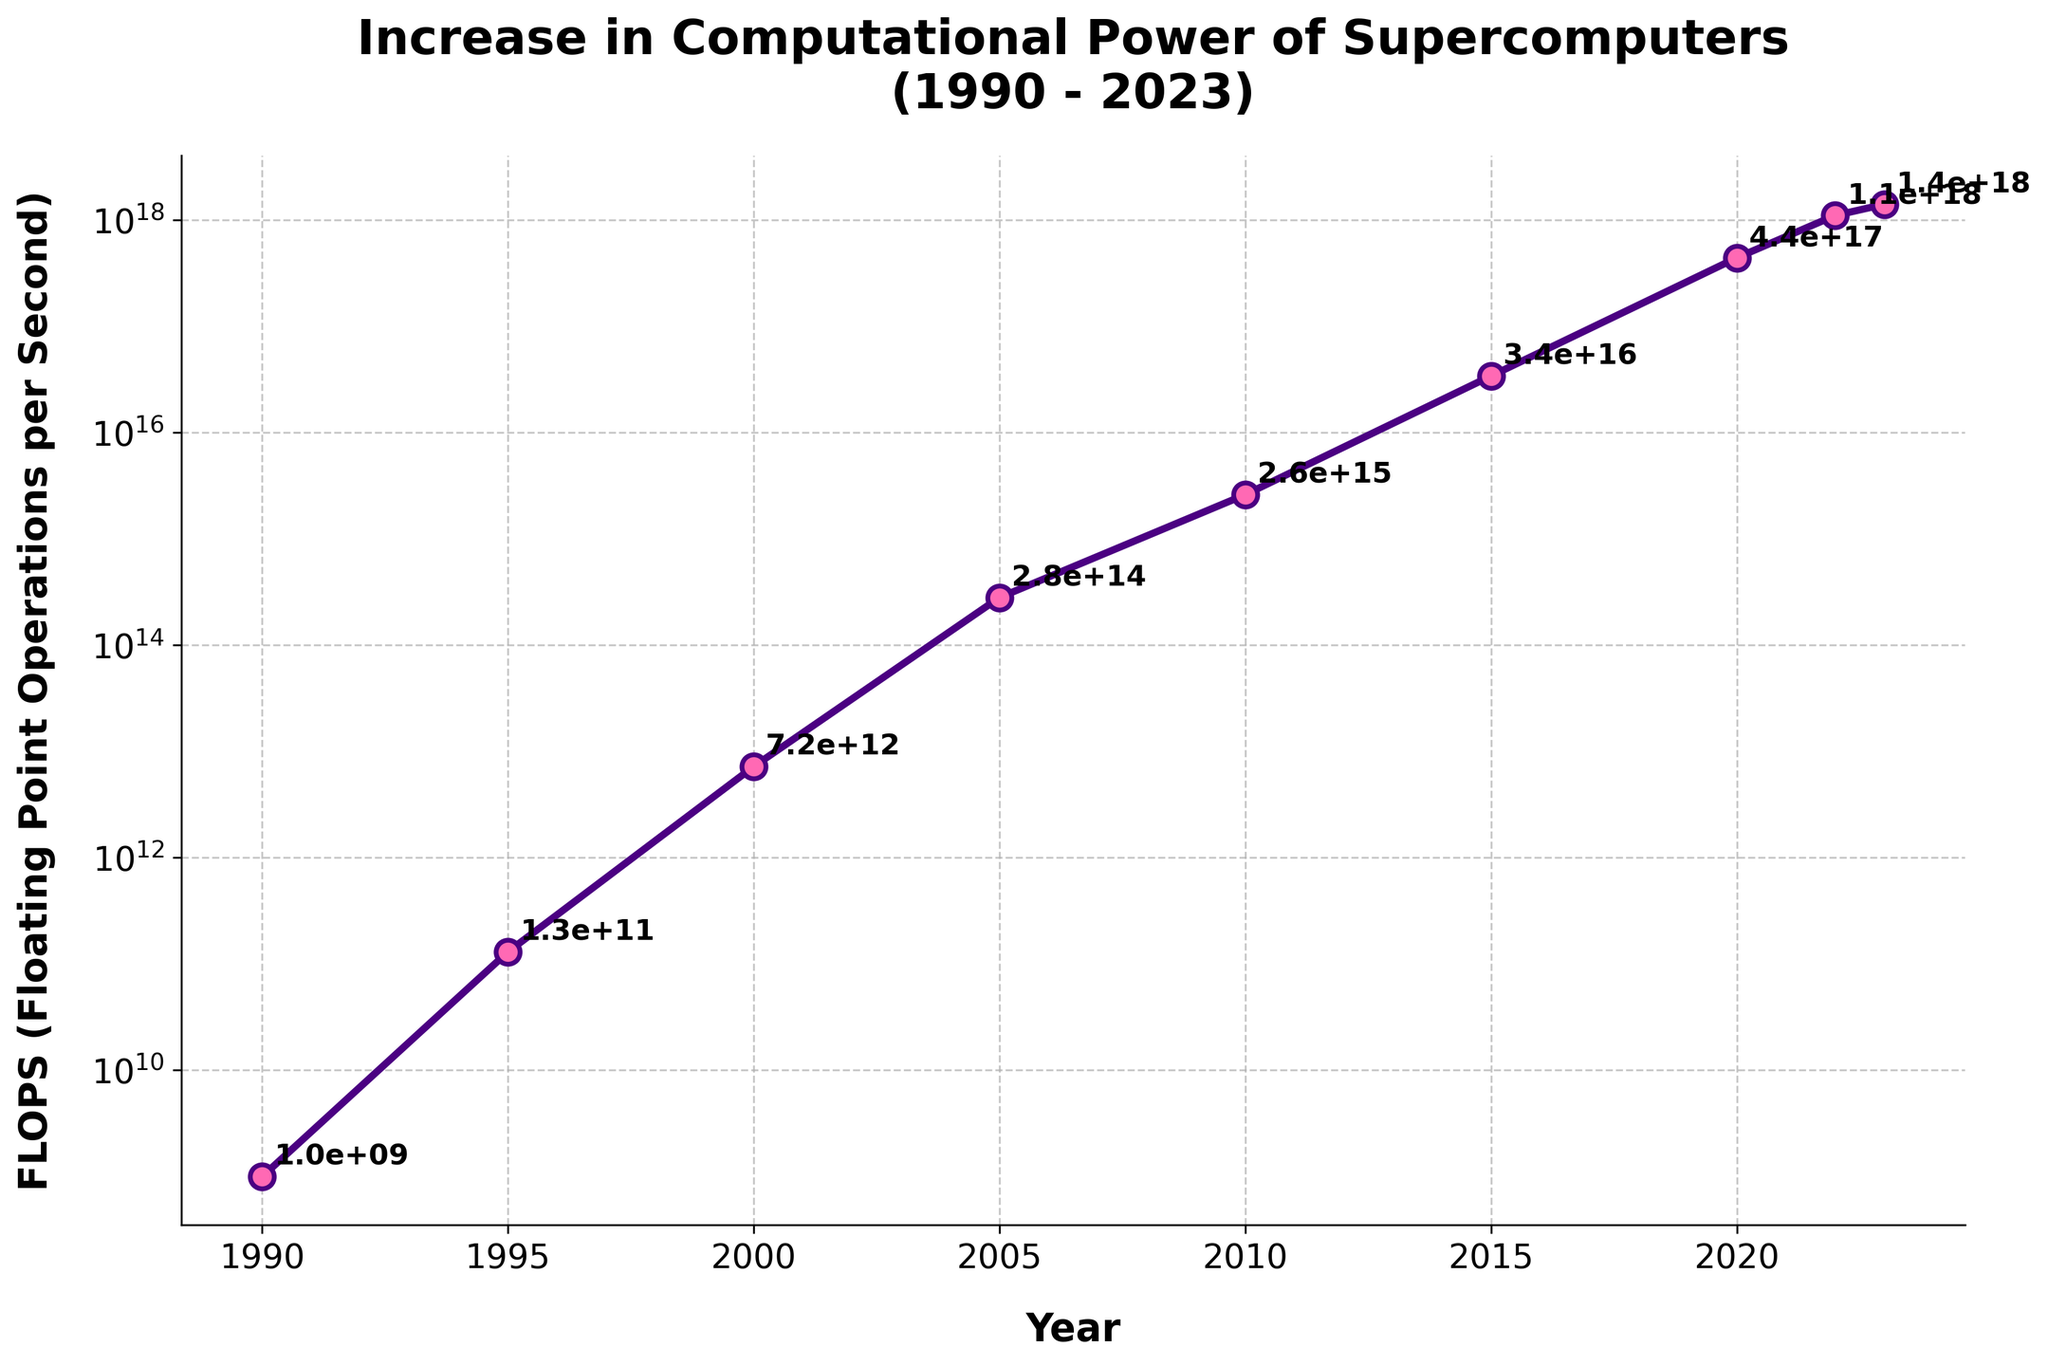What is the overall trend in computational power (FLOPS) from 1990 to 2023? The trend can be observed by simply looking at the line connecting the data points on the plot, which shows a general upward trajectory. This indicates that the computational power (FLOPS) of supercomputers has increased significantly from 1990 to 2023.
Answer: Increasing How many times did the computational power (FLOPS) of supercomputers increase from 1995 to 2020? To determine the increase, we divide the FLOPS value in 2020 by the FLOPS value in 1995: 4.4e+17 / 1.3e+11. This results in approximately 3.38e+6, indicating the computational power multiplied.
Answer: 3.38 million times In which year did supercomputers achieve a computational power (FLOPS) of around 1e+18? The year when FLOPS was closest to 1e+18 can be identified by locating the nearest data point on the plot. In this case, the year 2022 shows a computational power of 1.1e+18, which is closest to 1e+18.
Answer: 2022 Between which consecutive years was there the largest increase in computational power (FLOPS)? By looking at the steepness of the line segments connecting the data points, the largest increase can be calculated. The sharpest rise appears to be between 2020 and 2022, given that the values increased from 4.4e+17 to 1.1e+18.
Answer: 2020 to 2022 How did the computational power (FLOPS) change from 2005 to 2010? To find the percentage change, we compare the FLOPS in 2010 with that in 2005. The FLOPS in 2005 was 2.8e+14, and in 2010 it was 2.6e+15. The increase is (2.6e+15 - 2.8e+14)/2.8e+14 * 100%, which results in an approximately 828.57% increase.
Answer: 828.57% increase What is the average computational power (FLOPS) increase per year between 1990 and 2023? The total increase in FLOPS from 1990 (1.0e+9) to 2023 (1.4e+18) is calculated by subtracting the values (1.4e+18 - 1.0e+9). This value is then divided by the number of years (2023 - 1990 = 33) to obtain the average annual increase. The average increase per year is (1.4e+18 - 1.0e+9) / 33 ≈ 4.24e+16 FLOPS/year.
Answer: 4.24e+16 FLOPS/year Which year saw supercomputers reach 7.2e+12 FLOPS? By identifying the data point on the plot that matches 7.2e+12 FLOPS, it is evident that this level of computational power was achieved in the year 2000.
Answer: 2000 Plot the data point with the highest computational power (FLOPS) achieved. What year is associated with this? The highest point on the plot represents the maximum value of computational power, which corresponds to the year 2023 with a FLOPS of 1.4e+18.
Answer: 2023 How much did the computational power (FLOPS) increase from the year 2015 to 2020? The increase in FLOPS from 2015 (3.4e+16) to 2020 (4.4e+17) is obtained by subtracting the earlier year value from the later year value: 4.4e+17 - 3.4e+16. This results in an increase of 4.06e+17 FLOPS.
Answer: 4.06e+17 FLOPS 